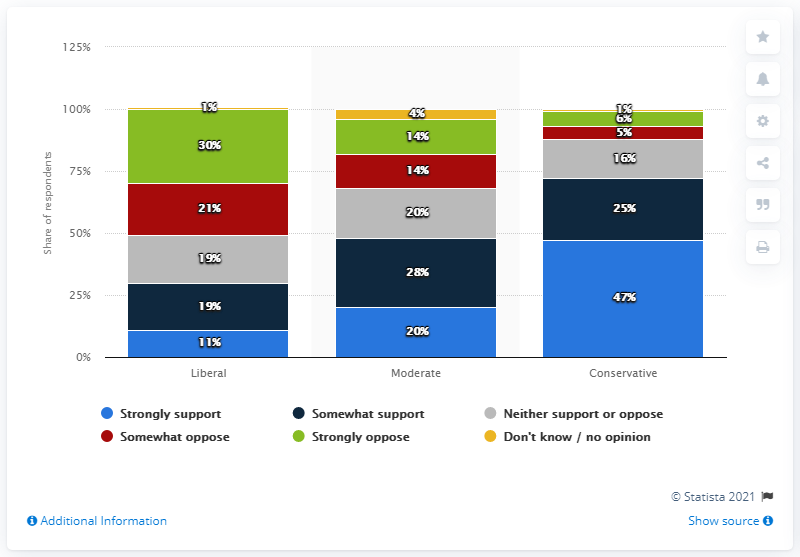Give some essential details in this illustration. Moderate political ideology is more equitable in its distribution of power and resources compared to other political ideologies. Approximately 6% of the people surveyed did not answer or had no opinion. 